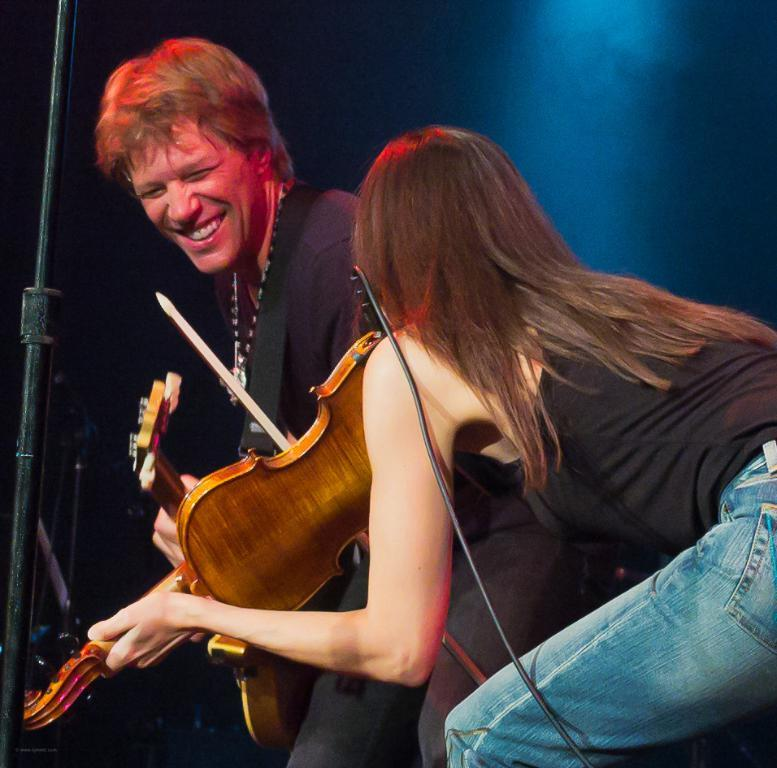How many people are present in the image? There are two people in the image. What are the people holding in their hands? Both people are holding guitars in their hands. What type of egg is being used to play the guitar in the image? There is no egg present in the image, and guitars are not played with eggs. 